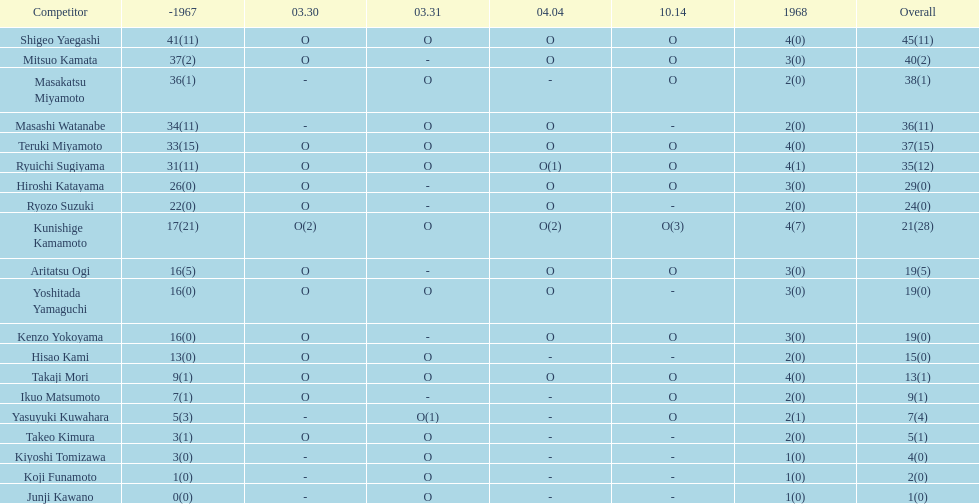What is the total number of appearances for masakatsu miyamoto? 38. 